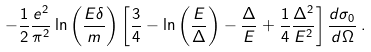<formula> <loc_0><loc_0><loc_500><loc_500>- \frac { 1 } { 2 } \frac { e ^ { 2 } } { \pi ^ { 2 } } \ln \left ( \frac { E \delta } { m } \right ) \left [ \frac { 3 } { 4 } - \ln \left ( \frac { E } { \Delta } \right ) - \frac { \Delta } { E } + \frac { 1 } { 4 } \frac { \Delta ^ { 2 } } { E ^ { 2 } } \right ] \frac { d \sigma _ { 0 } } { d \Omega } \, .</formula> 